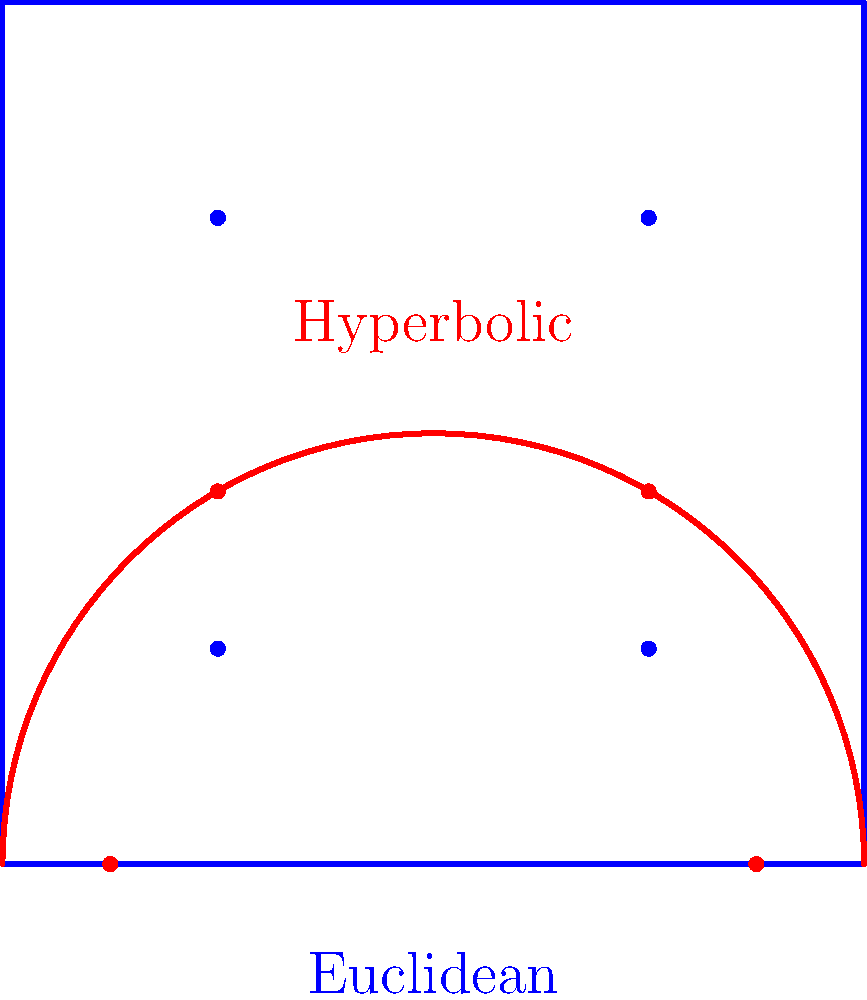In your journey to build stronger relationships with your stepsiblings, you've decided to organize a family game night focused on geometry puzzles. One puzzle compares quadrilaterals in different geometric spaces. Consider a quadrilateral ABCD on a flat (Euclidean) plane and a similar quadrilateral A'B'C'D' on a hyperbolic plane using the upper half-plane model. If the sum of interior angles in the Euclidean quadrilateral is $360^\circ$, what is the sum of interior angles in the hyperbolic quadrilateral?

a) Greater than $360^\circ$
b) Equal to $360^\circ$
c) Less than $360^\circ$
d) Cannot be determined Let's approach this step-by-step:

1) In Euclidean geometry, the sum of interior angles of any quadrilateral is always $360^\circ$ or $2\pi$ radians.

2) In hyperbolic geometry, the sum of angles in a triangle is always less than $180^\circ$. This property extends to other polygons as well.

3) We can divide a quadrilateral into two triangles by drawing a diagonal. In Euclidean geometry, this gives us:

   $$(180^\circ + 180^\circ) = 360^\circ$$

4) In hyperbolic geometry, each of these triangles will have an angle sum less than $180^\circ$. Let's call the defect from $180^\circ$ for each triangle $\delta_1$ and $\delta_2$. So, the sum of angles in the hyperbolic quadrilateral will be:

   $$((180^\circ - \delta_1) + (180^\circ - \delta_2)) = (360^\circ - (\delta_1 + \delta_2))$$

5) Since $\delta_1$ and $\delta_2$ are both positive, $(\delta_1 + \delta_2)$ is positive, making the total sum less than $360^\circ$.

This property holds true regardless of the specific shape or size of the quadrilateral in hyperbolic space.
Answer: c) Less than $360^\circ$ 